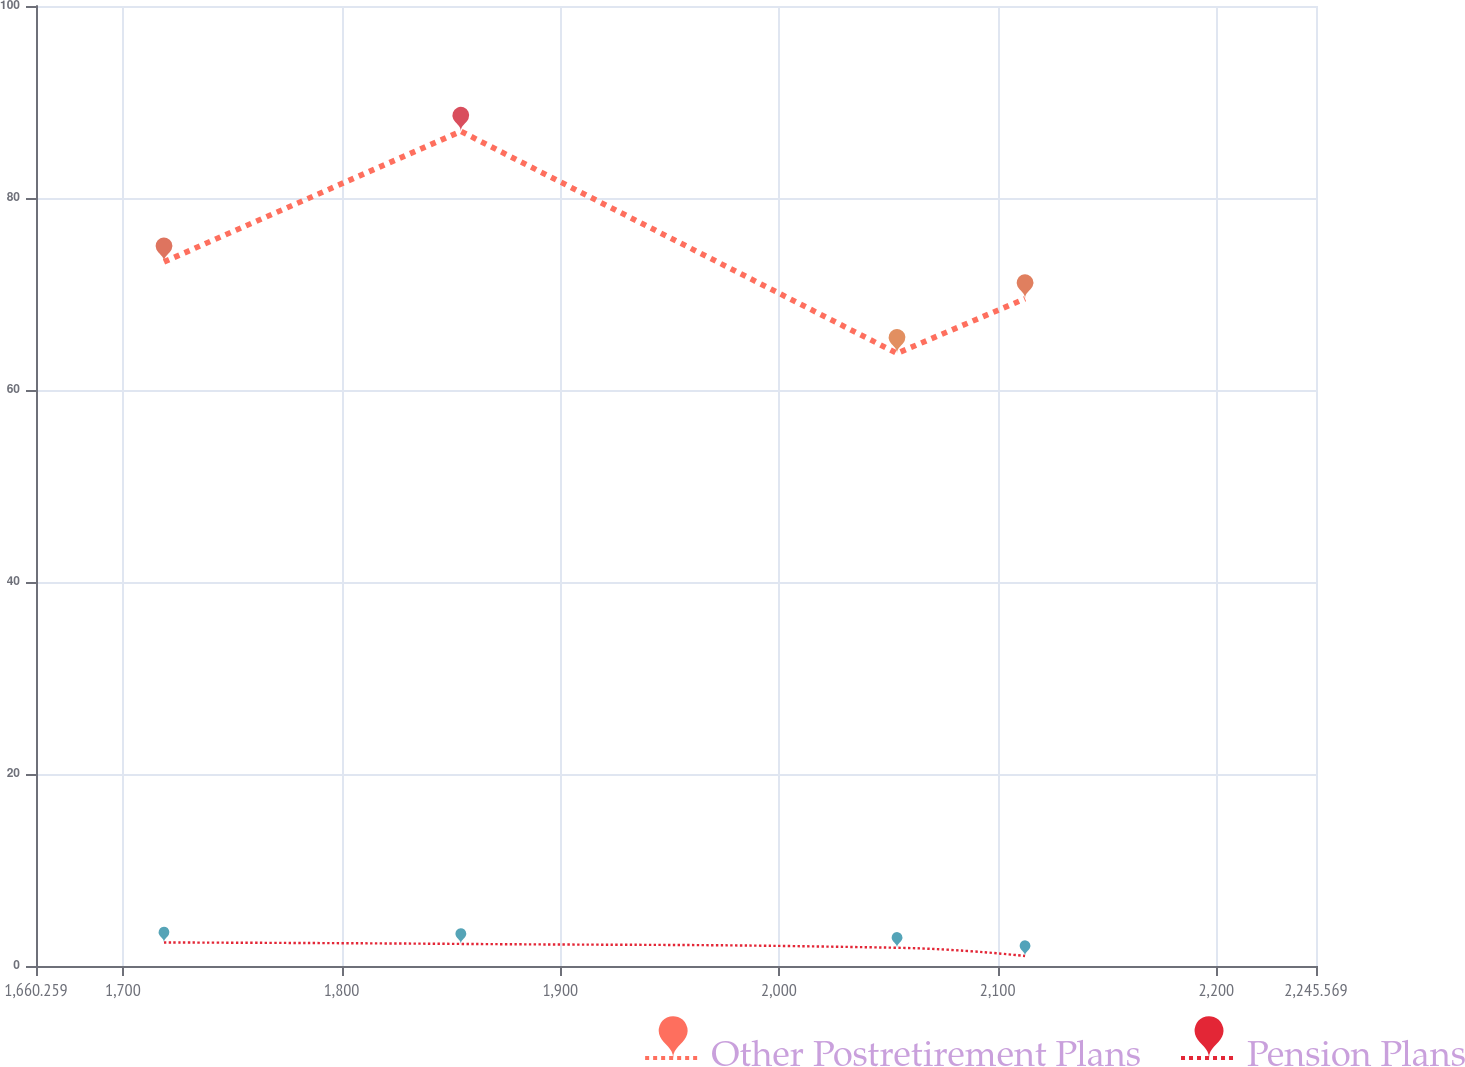Convert chart. <chart><loc_0><loc_0><loc_500><loc_500><line_chart><ecel><fcel>Other Postretirement Plans<fcel>Pension Plans<nl><fcel>1718.79<fcel>73.35<fcel>2.45<nl><fcel>1854.52<fcel>86.95<fcel>2.3<nl><fcel>2053.99<fcel>63.82<fcel>1.9<nl><fcel>2112.52<fcel>69.51<fcel>1.04<nl><fcel>2304.1<fcel>84.73<fcel>0.89<nl></chart> 